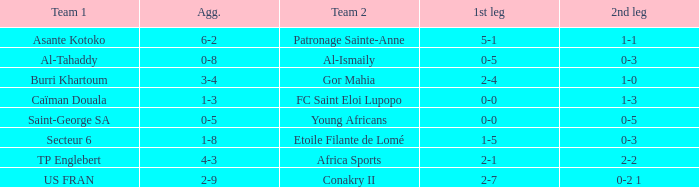Which group suffered 0-3 and 0-5 losses? Al-Tahaddy. 